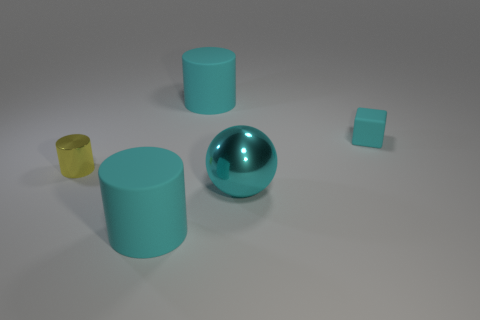The object that is the same size as the matte block is what shape?
Keep it short and to the point. Cylinder. Does the yellow shiny cylinder have the same size as the cyan cube?
Make the answer very short. Yes. How many things are either metallic objects right of the small cylinder or green rubber objects?
Provide a succinct answer. 1. How many other objects are the same size as the cyan rubber block?
Offer a very short reply. 1. The metal ball is what color?
Keep it short and to the point. Cyan. How many large things are either rubber cylinders or yellow things?
Provide a succinct answer. 2. Do the rubber cylinder in front of the tiny cyan rubber block and the thing that is on the right side of the big sphere have the same size?
Make the answer very short. No. Is the number of large cyan things that are behind the large metallic object greater than the number of cyan cylinders that are right of the tiny block?
Offer a terse response. Yes. The cyan thing that is to the left of the large cyan metallic thing and behind the cyan shiny sphere is made of what material?
Give a very brief answer. Rubber. The cyan metal sphere is what size?
Your answer should be compact. Large. 